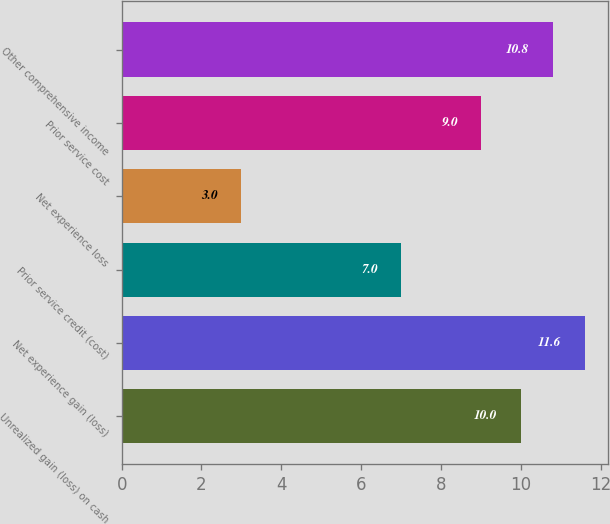Convert chart to OTSL. <chart><loc_0><loc_0><loc_500><loc_500><bar_chart><fcel>Unrealized gain (loss) on cash<fcel>Net experience gain (loss)<fcel>Prior service credit (cost)<fcel>Net experience loss<fcel>Prior service cost<fcel>Other comprehensive income<nl><fcel>10<fcel>11.6<fcel>7<fcel>3<fcel>9<fcel>10.8<nl></chart> 